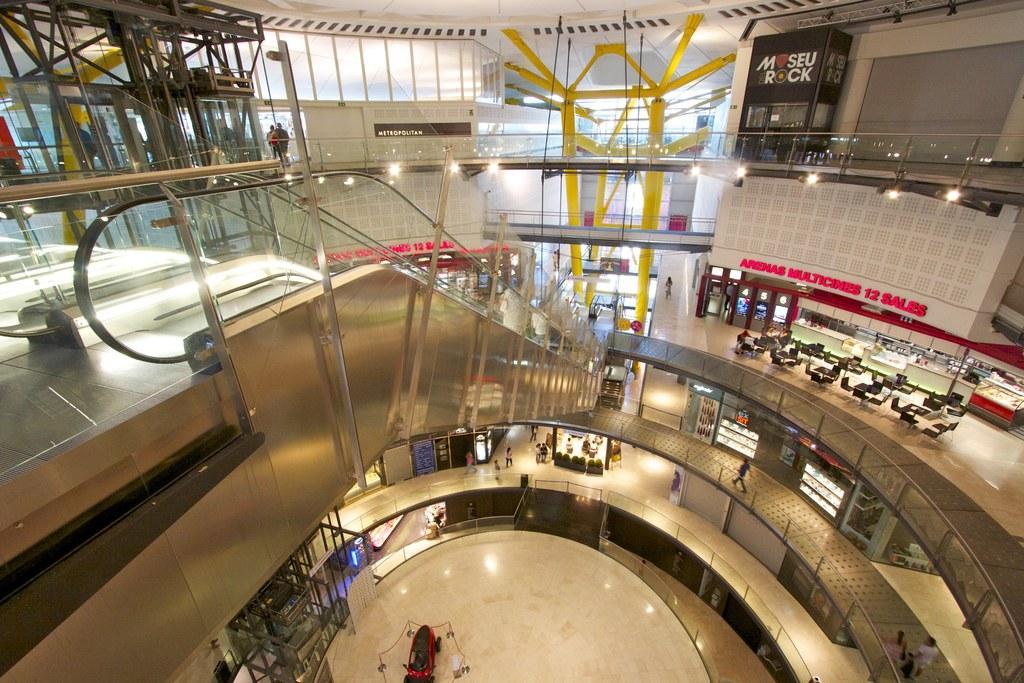In one or two sentences, can you explain what this image depicts? In this image we can see the inside view of a building, there are chairs, tables, boards with text on them, there are a few people, there is an escalator, there are railings, lights. 